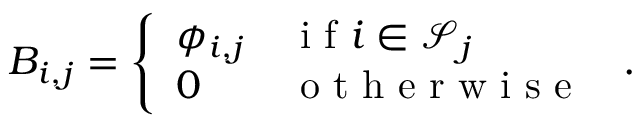<formula> <loc_0><loc_0><loc_500><loc_500>{ B } _ { i , j } = \left \{ \begin{array} { l l } { \phi _ { i , j } } & { i f i \in \ m a t h s c r { S } _ { j } } \\ { 0 } & { o t h e r w i s e } \end{array} \, .</formula> 